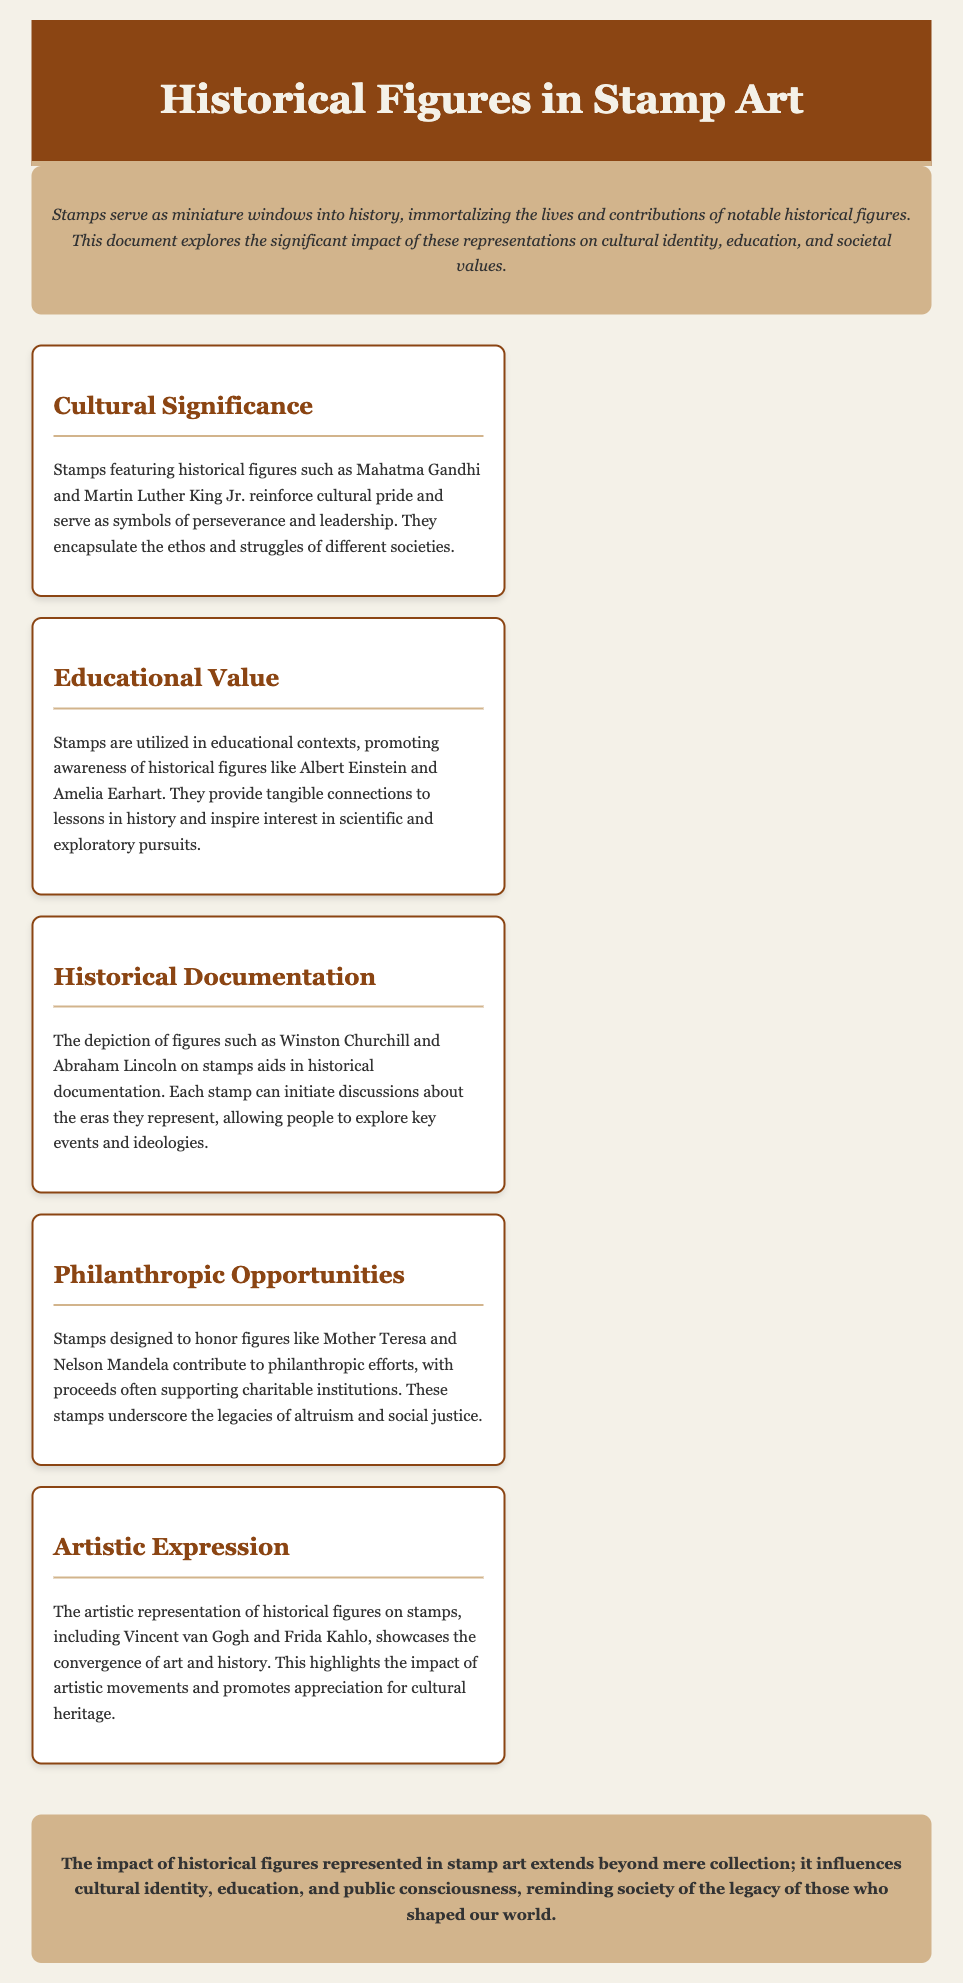What is the main theme of the document? The document explores the impact of historical figures represented in stamp art on cultural identity, education, and societal values.
Answer: Impact of historical figures Who are mentioned as examples of historical figures in the cultural significance section? The cultural significance section mentions Mahatma Gandhi and Martin Luther King Jr. as examples of historical figures on stamps.
Answer: Mahatma Gandhi and Martin Luther King Jr Which historical figure is highlighted in the educational value section? The educational value section highlights historical figures like Albert Einstein and Amelia Earhart to demonstrate their significance in education.
Answer: Albert Einstein and Amelia Earhart How does the document describe the role of stamps featuring Winston Churchill? The document states that stamps featuring Winston Churchill aid in historical documentation and initiate discussions about key events.
Answer: Aid in historical documentation What type of philanthropic figures are mentioned in connection with stamps? The philanthropic opportunities section mentions figures like Mother Teresa and Nelson Mandela in relation to stamps designed to honor them.
Answer: Mother Teresa and Nelson Mandela What artistic movements are highlighted in the artistic expression section? The artistic expression section showcases the impact of artistic movements through figures like Vincent van Gogh and Frida Kahlo on stamps.
Answer: Vincent van Gogh and Frida Kahlo What is the concluding statement of the document? The conclusion reinforces the broader impact of historical figures on cultural identity and public consciousness through stamp art.
Answer: Influence on cultural identity and public consciousness How many sections are in the menu? The document has five sections detailing different aspects of the impact of historical figures in stamp art.
Answer: Five sections 